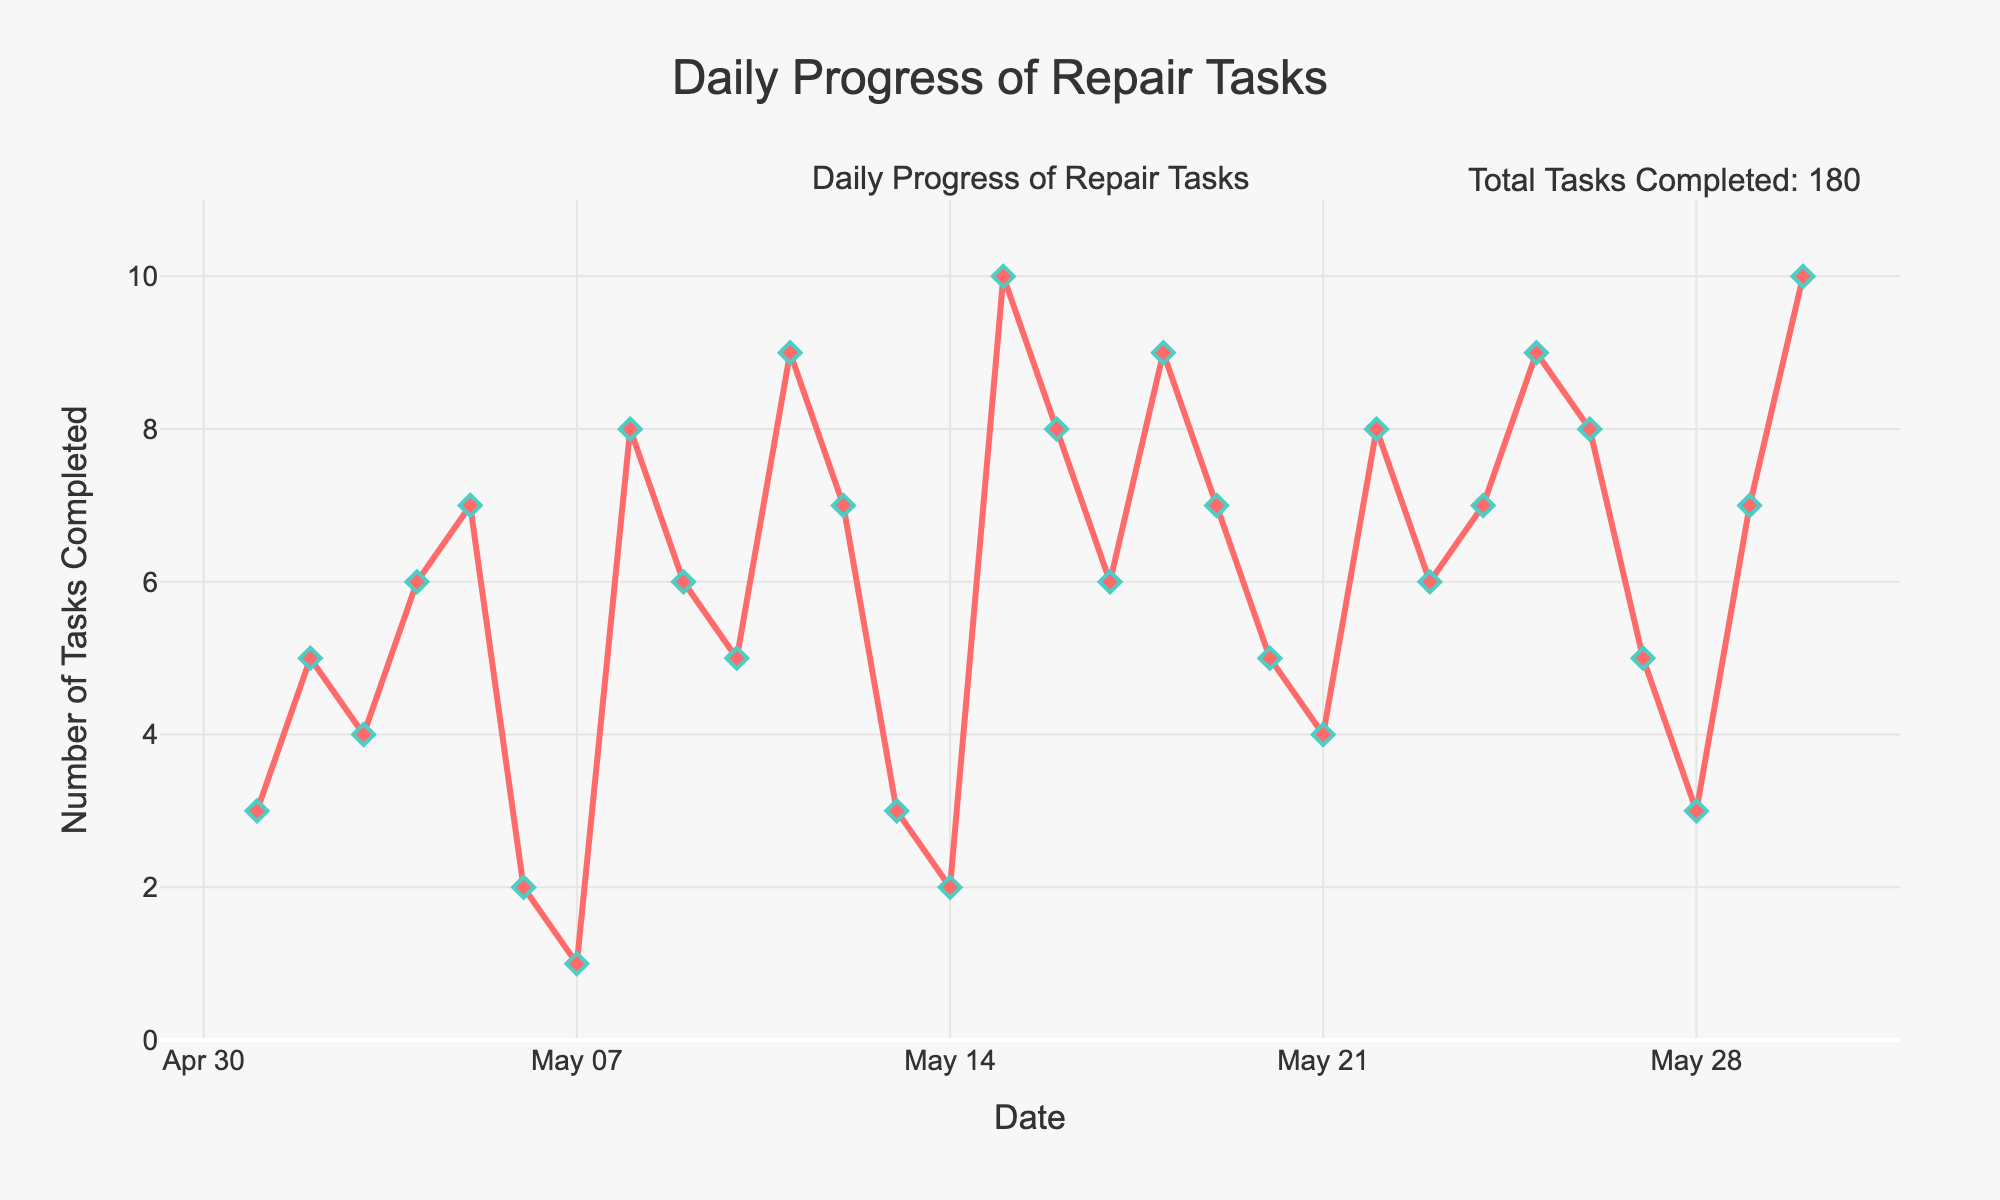When was the highest number of tasks completed, and how many tasks were completed on that day? The highest number of tasks completed was on May 15 and May 30. By looking at the y-axis and the data points on the chart, we find that 10 tasks were completed on each of those days.
Answer: May 15 and May 30, 10 tasks How many tasks were completed in total over the entire time period? The plot includes an annotation that displays the total number of tasks completed. Thus, we don't need to calculate it again; we can directly read from the annotation that the total number of tasks completed is 175.
Answer: 175 On which day(s) were the least number of tasks completed, and how many tasks were those? The least number of tasks completed in a day is 1, as shown by the lowest point on the y-axis. This occurred on May 7.
Answer: May 7, 1 task How does the number of tasks completed on May 8 compare to May 7? Comparing the two consecutive points for May 7 and May 8 on the line chart, you see that the number of tasks completed rises from 1 on May 7 to 8 on May 8.
Answer: May 8 is 7 tasks more than May 7 What's the average number of tasks completed per day over the month? First, we need to sum the total number of tasks completed, which is 175. Then we divide by the number of days in May, which is 30. Calculation: 175 / 30 = 5.83 (approximately).
Answer: Approximately 5.83 What is the range of the number of tasks completed? The range is the difference between the maximum and minimum numbers. From the chart, the maximum is 10 and the minimum is 1. Therefore, the range is 10 - 1 = 9.
Answer: 9 How many days recorded the completion of more than 6 tasks? Identifying the days on the plot where the y-value exceeds 6, we count that there are 10 days where more than 6 tasks were completed.
Answer: 10 days Which day(s) showed a decrease in the number of tasks completed compared to the previous day? By looking at the line chart, the points where the line drops from one day to the next, you notice that there are several days: May 6, May 7, May 10, May 13, May 14, May 20, and May 27.
Answer: May 6, May 7, May 10, May 13, May 14, May 20, May 27 What's the difference in the number of tasks completed between May 19 and May 21? On May 19, 7 tasks were completed, and on May 21, 4 tasks were completed. The difference is 7 - 4 = 3 tasks.
Answer: 3 tasks How many days had exactly 5 tasks completed? By counting the data points at y=5 on the line chart, we see that there are 4 days: May 2, May 10, May 20, and May 27.
Answer: 4 days 